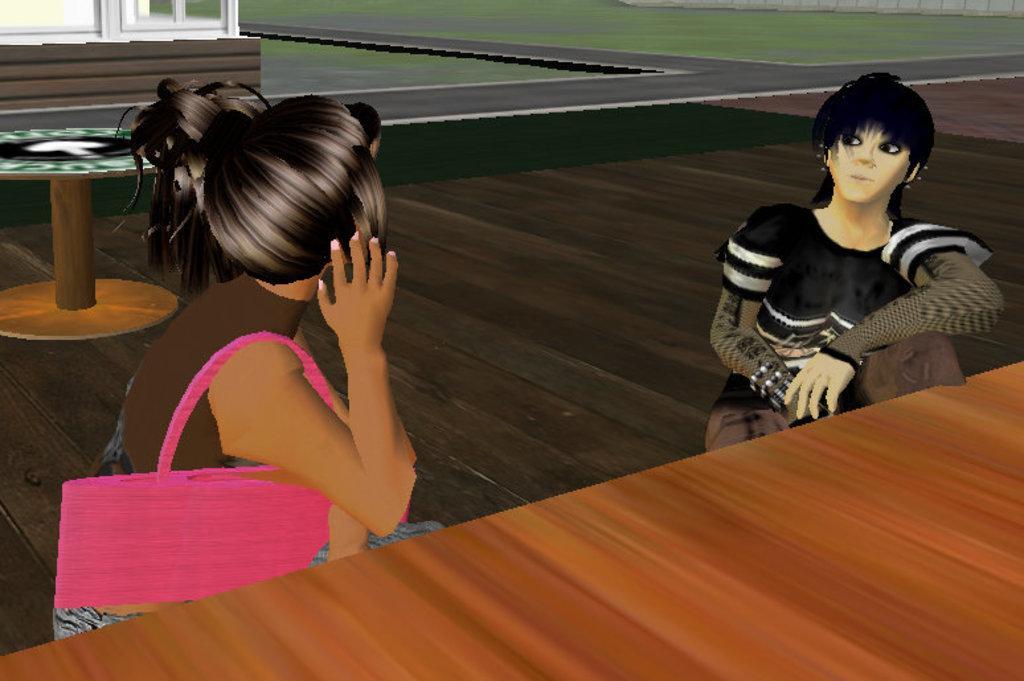Please provide a concise description of this image. This is an animated image in this image there are two women sitting on chairs and talking with each other, in front of them there is a table, behind them there is a road, on the road there is an object, on the other side of the road there is a building and there's grass on the surface 